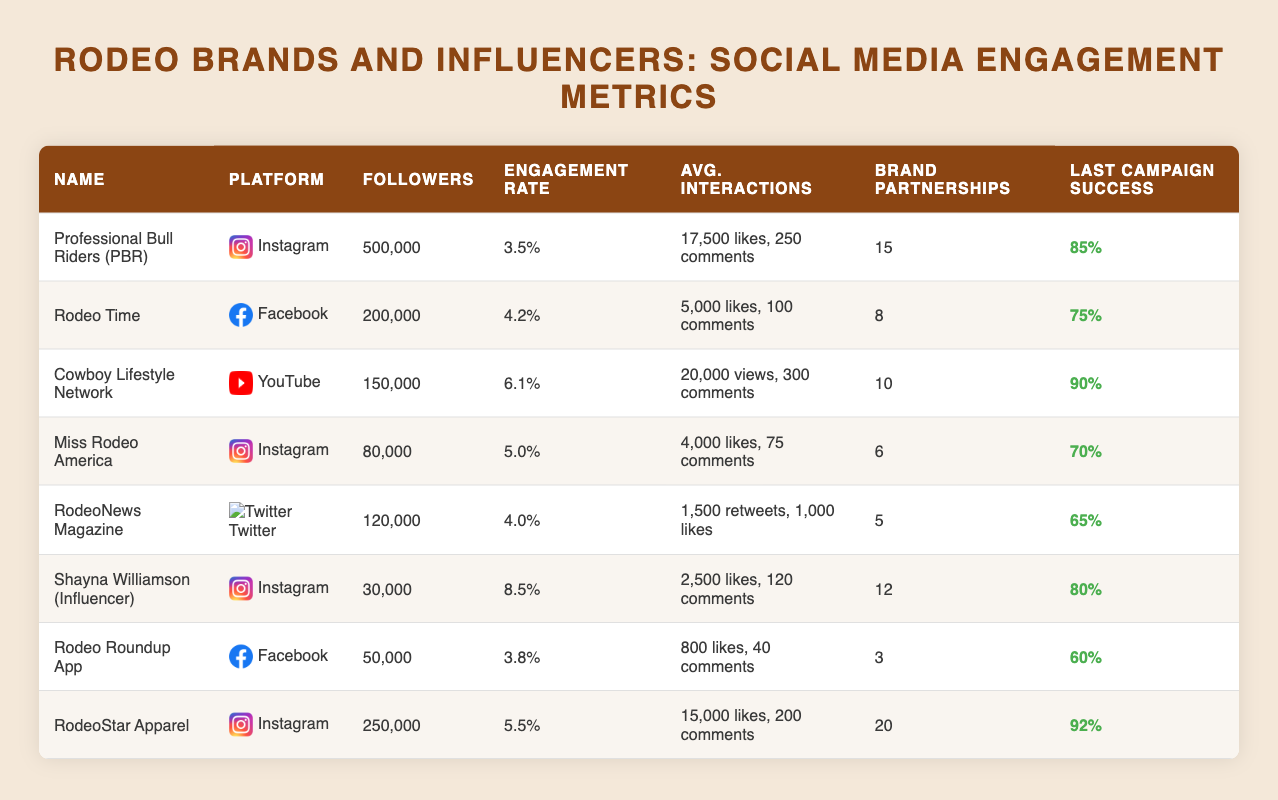What is the highest average engagement rate among the listed rodeo brands and influencers? The table shows the average engagement rates for each rodeo brand and influencer. By comparing the values, Shayna Williamson has the highest average engagement rate at 8.5%.
Answer: 8.5% How many brand partnerships does RodeoStar Apparel have? According to the table, RodeoStar Apparel has 20 brand partnerships listed under the relevant column.
Answer: 20 Which platform does the Cowboy Lifestyle Network use? The table provides a column for platforms used by each influencer. Cowboy Lifestyle Network is associated with YouTube.
Answer: YouTube What is the combined number of followers for Professional Bull Riders and Rodeo Time? To find the combined followers, we add the followers of the two: Professional Bull Riders has 500,000 followers and Rodeo Time has 200,000 followers. The total is 500,000 + 200,000 = 700,000.
Answer: 700,000 Is Miss Rodeo America more successful in terms of campaign success rate compared to RodeoNews Magazine? The last campaign success rate for Miss Rodeo America is 70% and for RodeoNews Magazine, it is 65%. Since 70% is greater than 65%, Miss Rodeo America is more successful.
Answer: Yes What are the average likes per post for Rodeo Star Apparel? From the table, Rodeo Star Apparel has an average of 15,000 likes per post listed under the average interactions column.
Answer: 15,000 What is the percentage difference in campaign success rates between the most and least successful brands in the table? The most successful is RodeoStar Apparel at 92% and the least successful is RodeoNews Magazine at 65%. The difference is 92% - 65% = 27%.
Answer: 27% Which influencer has the least number of followers? By examining the followers column, Shayna Williamson has 30,000 followers, which is the lowest among the listed influencers and brands.
Answer: Shayna Williamson What is the average engagement rate for Rodeo brands using Instagram? There are three brands using Instagram: Professional Bull Riders (3.5%), Miss Rodeo America (5.0%), and Shayna Williamson (8.5%). The average is (3.5% + 5.0% + 8.5%)/3 = 5.33%.
Answer: 5.33% 